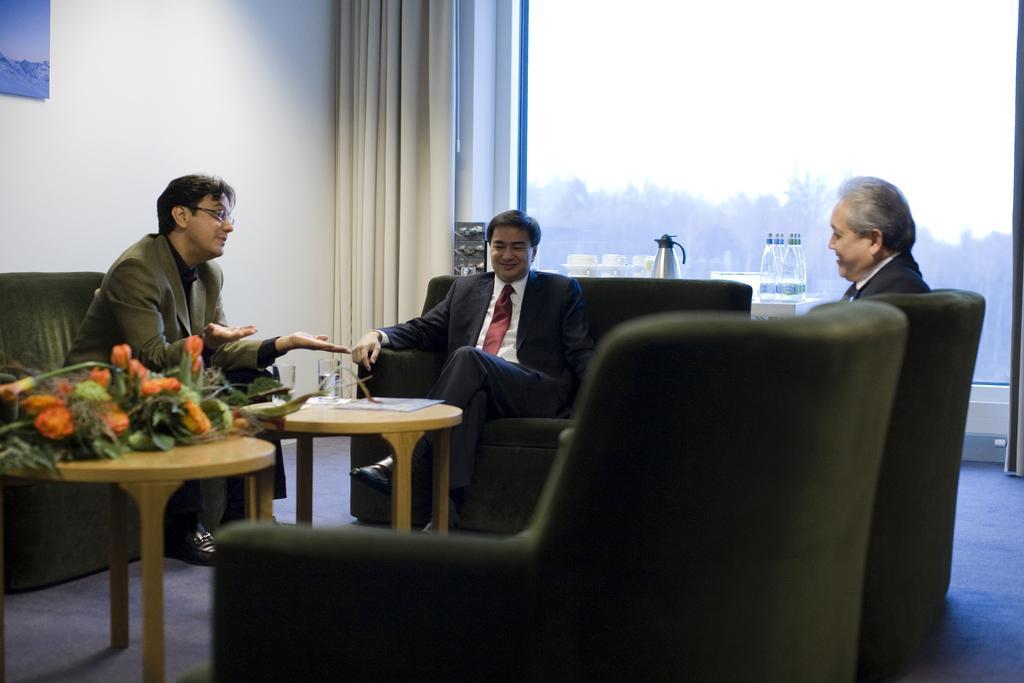Could you give a brief overview of what you see in this image? As we can see in the image there is a white color wall, curtain, window, three people sitting on sofa and a table. On table there are flowers. 